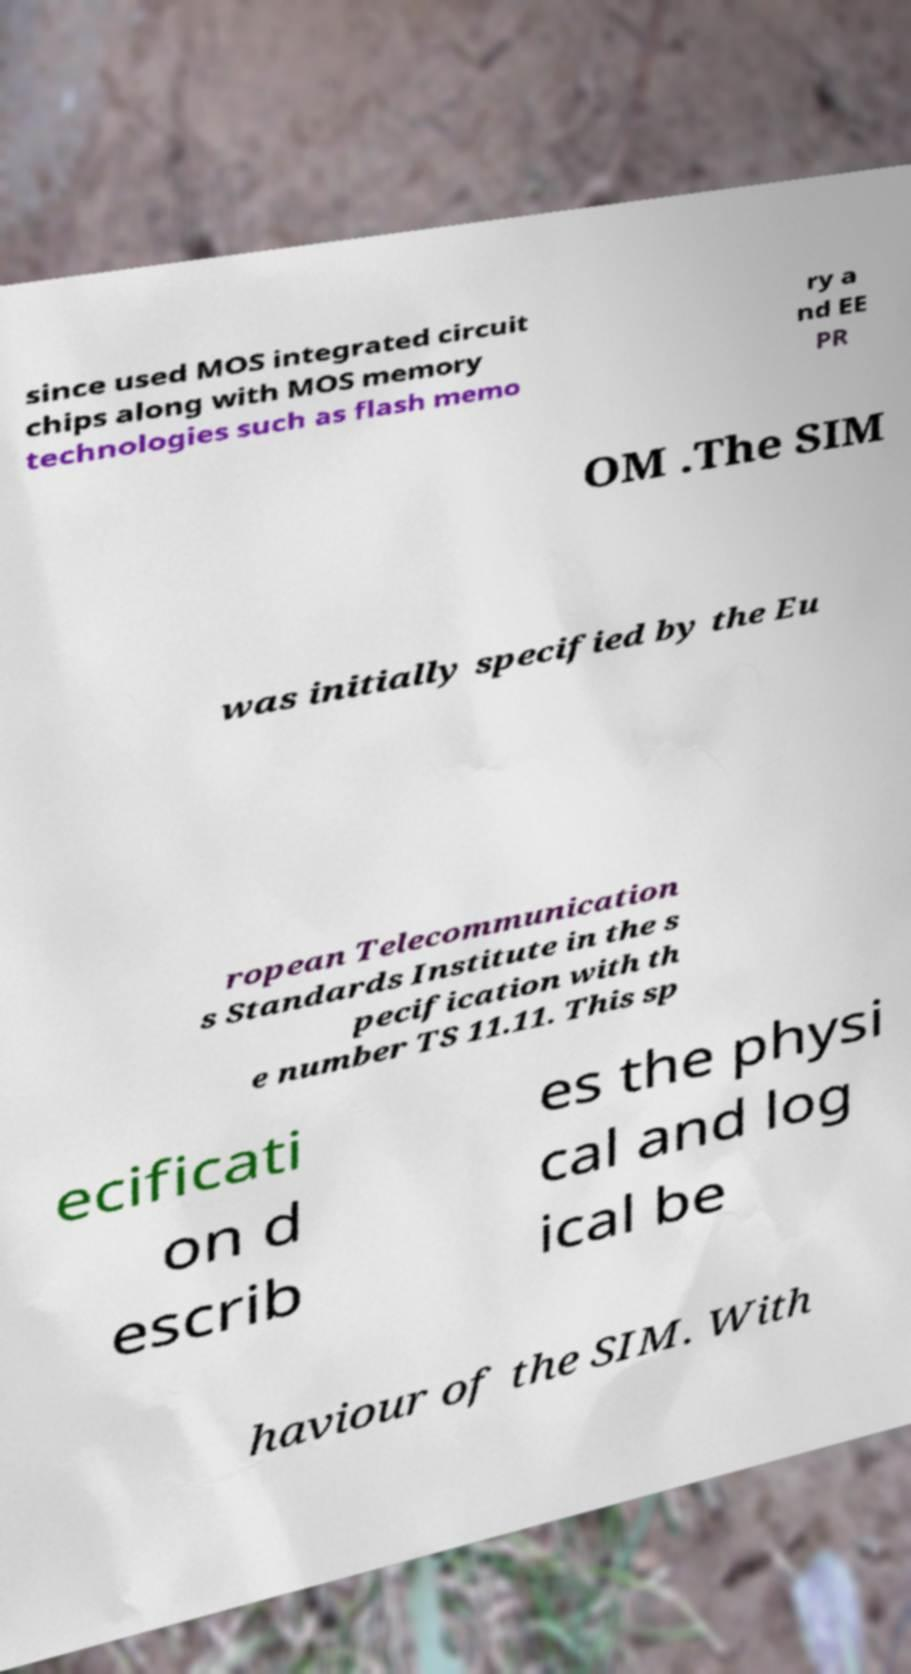I need the written content from this picture converted into text. Can you do that? since used MOS integrated circuit chips along with MOS memory technologies such as flash memo ry a nd EE PR OM .The SIM was initially specified by the Eu ropean Telecommunication s Standards Institute in the s pecification with th e number TS 11.11. This sp ecificati on d escrib es the physi cal and log ical be haviour of the SIM. With 